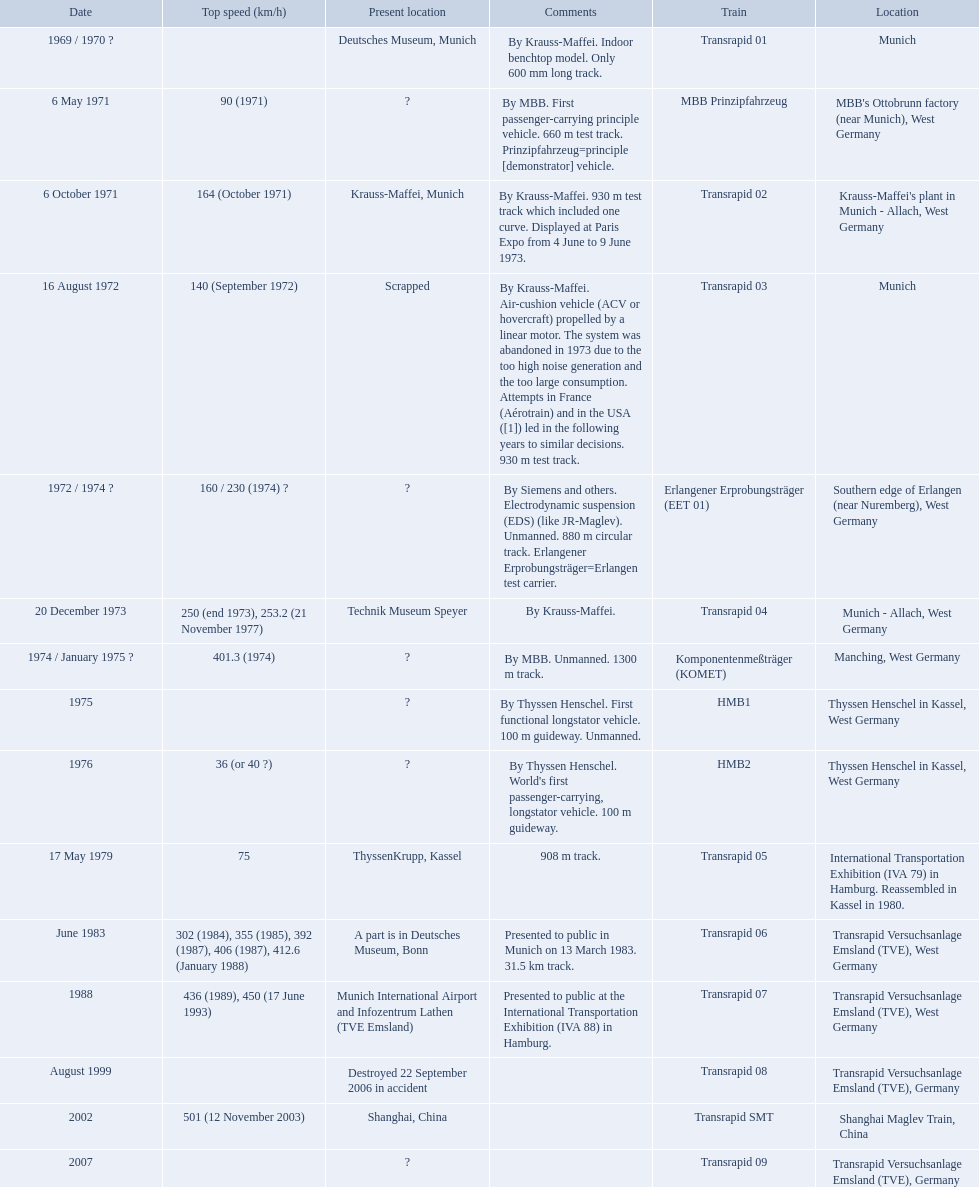What are all trains? Transrapid 01, MBB Prinzipfahrzeug, Transrapid 02, Transrapid 03, Erlangener Erprobungsträger (EET 01), Transrapid 04, Komponentenmeßträger (KOMET), HMB1, HMB2, Transrapid 05, Transrapid 06, Transrapid 07, Transrapid 08, Transrapid SMT, Transrapid 09. Can you parse all the data within this table? {'header': ['Date', 'Top speed (km/h)', 'Present location', 'Comments', 'Train', 'Location'], 'rows': [['1969 / 1970\xa0?', '', 'Deutsches Museum, Munich', 'By Krauss-Maffei. Indoor benchtop model. Only 600\xa0mm long track.', 'Transrapid 01', 'Munich'], ['6 May 1971', '90 (1971)', '?', 'By MBB. First passenger-carrying principle vehicle. 660 m test track. Prinzipfahrzeug=principle [demonstrator] vehicle.', 'MBB Prinzipfahrzeug', "MBB's Ottobrunn factory (near Munich), West Germany"], ['6 October 1971', '164 (October 1971)', 'Krauss-Maffei, Munich', 'By Krauss-Maffei. 930 m test track which included one curve. Displayed at Paris Expo from 4 June to 9 June 1973.', 'Transrapid 02', "Krauss-Maffei's plant in Munich - Allach, West Germany"], ['16 August 1972', '140 (September 1972)', 'Scrapped', 'By Krauss-Maffei. Air-cushion vehicle (ACV or hovercraft) propelled by a linear motor. The system was abandoned in 1973 due to the too high noise generation and the too large consumption. Attempts in France (Aérotrain) and in the USA ([1]) led in the following years to similar decisions. 930 m test track.', 'Transrapid 03', 'Munich'], ['1972 / 1974\xa0?', '160 / 230 (1974)\xa0?', '?', 'By Siemens and others. Electrodynamic suspension (EDS) (like JR-Maglev). Unmanned. 880 m circular track. Erlangener Erprobungsträger=Erlangen test carrier.', 'Erlangener Erprobungsträger (EET 01)', 'Southern edge of Erlangen (near Nuremberg), West Germany'], ['20 December 1973', '250 (end 1973), 253.2 (21 November 1977)', 'Technik Museum Speyer', 'By Krauss-Maffei.', 'Transrapid 04', 'Munich - Allach, West Germany'], ['1974 / January 1975\xa0?', '401.3 (1974)', '?', 'By MBB. Unmanned. 1300 m track.', 'Komponentenmeßträger (KOMET)', 'Manching, West Germany'], ['1975', '', '?', 'By Thyssen Henschel. First functional longstator vehicle. 100 m guideway. Unmanned.', 'HMB1', 'Thyssen Henschel in Kassel, West Germany'], ['1976', '36 (or 40\xa0?)', '?', "By Thyssen Henschel. World's first passenger-carrying, longstator vehicle. 100 m guideway.", 'HMB2', 'Thyssen Henschel in Kassel, West Germany'], ['17 May 1979', '75', 'ThyssenKrupp, Kassel', '908 m track.', 'Transrapid 05', 'International Transportation Exhibition (IVA 79) in Hamburg. Reassembled in Kassel in 1980.'], ['June 1983', '302 (1984), 355 (1985), 392 (1987), 406 (1987), 412.6 (January 1988)', 'A part is in Deutsches Museum, Bonn', 'Presented to public in Munich on 13 March 1983. 31.5\xa0km track.', 'Transrapid 06', 'Transrapid Versuchsanlage Emsland (TVE), West Germany'], ['1988', '436 (1989), 450 (17 June 1993)', 'Munich International Airport and Infozentrum Lathen (TVE Emsland)', 'Presented to public at the International Transportation Exhibition (IVA 88) in Hamburg.', 'Transrapid 07', 'Transrapid Versuchsanlage Emsland (TVE), West Germany'], ['August 1999', '', 'Destroyed 22 September 2006 in accident', '', 'Transrapid 08', 'Transrapid Versuchsanlage Emsland (TVE), Germany'], ['2002', '501 (12 November 2003)', 'Shanghai, China', '', 'Transrapid SMT', 'Shanghai Maglev Train, China'], ['2007', '', '?', '', 'Transrapid 09', 'Transrapid Versuchsanlage Emsland (TVE), Germany']]} Which of all location of trains are known? Deutsches Museum, Munich, Krauss-Maffei, Munich, Scrapped, Technik Museum Speyer, ThyssenKrupp, Kassel, A part is in Deutsches Museum, Bonn, Munich International Airport and Infozentrum Lathen (TVE Emsland), Destroyed 22 September 2006 in accident, Shanghai, China. Which of those trains were scrapped? Transrapid 03. 